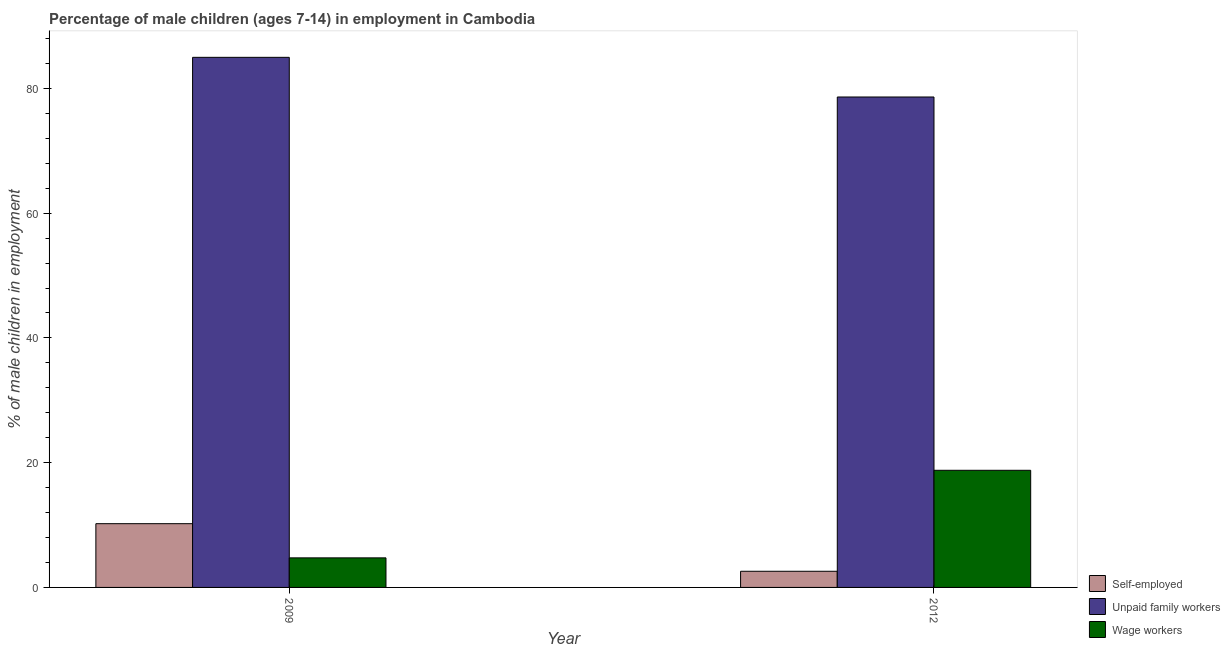Are the number of bars per tick equal to the number of legend labels?
Provide a succinct answer. Yes. How many bars are there on the 1st tick from the left?
Your answer should be compact. 3. What is the percentage of self employed children in 2012?
Your response must be concise. 2.59. Across all years, what is the maximum percentage of self employed children?
Provide a succinct answer. 10.22. Across all years, what is the minimum percentage of self employed children?
Ensure brevity in your answer.  2.59. In which year was the percentage of children employed as wage workers maximum?
Provide a short and direct response. 2012. In which year was the percentage of children employed as unpaid family workers minimum?
Your answer should be very brief. 2012. What is the total percentage of self employed children in the graph?
Your answer should be compact. 12.81. What is the difference between the percentage of self employed children in 2009 and that in 2012?
Provide a succinct answer. 7.63. What is the difference between the percentage of children employed as wage workers in 2012 and the percentage of self employed children in 2009?
Your answer should be compact. 14.04. What is the average percentage of children employed as unpaid family workers per year?
Provide a succinct answer. 81.81. In how many years, is the percentage of children employed as unpaid family workers greater than 28 %?
Your answer should be compact. 2. What is the ratio of the percentage of children employed as unpaid family workers in 2009 to that in 2012?
Provide a short and direct response. 1.08. What does the 2nd bar from the left in 2009 represents?
Ensure brevity in your answer.  Unpaid family workers. What does the 1st bar from the right in 2012 represents?
Offer a very short reply. Wage workers. Is it the case that in every year, the sum of the percentage of self employed children and percentage of children employed as unpaid family workers is greater than the percentage of children employed as wage workers?
Keep it short and to the point. Yes. How many bars are there?
Keep it short and to the point. 6. Are all the bars in the graph horizontal?
Offer a terse response. No. How many years are there in the graph?
Offer a terse response. 2. Are the values on the major ticks of Y-axis written in scientific E-notation?
Provide a succinct answer. No. Does the graph contain any zero values?
Your answer should be very brief. No. Where does the legend appear in the graph?
Give a very brief answer. Bottom right. What is the title of the graph?
Offer a terse response. Percentage of male children (ages 7-14) in employment in Cambodia. What is the label or title of the Y-axis?
Keep it short and to the point. % of male children in employment. What is the % of male children in employment of Self-employed in 2009?
Your response must be concise. 10.22. What is the % of male children in employment of Unpaid family workers in 2009?
Provide a succinct answer. 84.99. What is the % of male children in employment in Wage workers in 2009?
Keep it short and to the point. 4.74. What is the % of male children in employment of Self-employed in 2012?
Your answer should be very brief. 2.59. What is the % of male children in employment of Unpaid family workers in 2012?
Provide a short and direct response. 78.63. What is the % of male children in employment in Wage workers in 2012?
Make the answer very short. 18.78. Across all years, what is the maximum % of male children in employment of Self-employed?
Keep it short and to the point. 10.22. Across all years, what is the maximum % of male children in employment in Unpaid family workers?
Make the answer very short. 84.99. Across all years, what is the maximum % of male children in employment in Wage workers?
Give a very brief answer. 18.78. Across all years, what is the minimum % of male children in employment of Self-employed?
Keep it short and to the point. 2.59. Across all years, what is the minimum % of male children in employment in Unpaid family workers?
Provide a short and direct response. 78.63. Across all years, what is the minimum % of male children in employment of Wage workers?
Your answer should be very brief. 4.74. What is the total % of male children in employment of Self-employed in the graph?
Provide a short and direct response. 12.81. What is the total % of male children in employment in Unpaid family workers in the graph?
Your response must be concise. 163.62. What is the total % of male children in employment of Wage workers in the graph?
Your answer should be very brief. 23.52. What is the difference between the % of male children in employment of Self-employed in 2009 and that in 2012?
Make the answer very short. 7.63. What is the difference between the % of male children in employment of Unpaid family workers in 2009 and that in 2012?
Provide a short and direct response. 6.36. What is the difference between the % of male children in employment in Wage workers in 2009 and that in 2012?
Offer a very short reply. -14.04. What is the difference between the % of male children in employment in Self-employed in 2009 and the % of male children in employment in Unpaid family workers in 2012?
Provide a short and direct response. -68.41. What is the difference between the % of male children in employment in Self-employed in 2009 and the % of male children in employment in Wage workers in 2012?
Give a very brief answer. -8.56. What is the difference between the % of male children in employment of Unpaid family workers in 2009 and the % of male children in employment of Wage workers in 2012?
Ensure brevity in your answer.  66.21. What is the average % of male children in employment in Self-employed per year?
Your response must be concise. 6.41. What is the average % of male children in employment of Unpaid family workers per year?
Offer a terse response. 81.81. What is the average % of male children in employment in Wage workers per year?
Make the answer very short. 11.76. In the year 2009, what is the difference between the % of male children in employment of Self-employed and % of male children in employment of Unpaid family workers?
Your response must be concise. -74.77. In the year 2009, what is the difference between the % of male children in employment of Self-employed and % of male children in employment of Wage workers?
Your answer should be compact. 5.48. In the year 2009, what is the difference between the % of male children in employment in Unpaid family workers and % of male children in employment in Wage workers?
Your answer should be very brief. 80.25. In the year 2012, what is the difference between the % of male children in employment in Self-employed and % of male children in employment in Unpaid family workers?
Provide a succinct answer. -76.04. In the year 2012, what is the difference between the % of male children in employment in Self-employed and % of male children in employment in Wage workers?
Keep it short and to the point. -16.19. In the year 2012, what is the difference between the % of male children in employment in Unpaid family workers and % of male children in employment in Wage workers?
Offer a terse response. 59.85. What is the ratio of the % of male children in employment of Self-employed in 2009 to that in 2012?
Give a very brief answer. 3.95. What is the ratio of the % of male children in employment of Unpaid family workers in 2009 to that in 2012?
Your answer should be very brief. 1.08. What is the ratio of the % of male children in employment of Wage workers in 2009 to that in 2012?
Make the answer very short. 0.25. What is the difference between the highest and the second highest % of male children in employment of Self-employed?
Provide a short and direct response. 7.63. What is the difference between the highest and the second highest % of male children in employment of Unpaid family workers?
Keep it short and to the point. 6.36. What is the difference between the highest and the second highest % of male children in employment in Wage workers?
Keep it short and to the point. 14.04. What is the difference between the highest and the lowest % of male children in employment in Self-employed?
Provide a short and direct response. 7.63. What is the difference between the highest and the lowest % of male children in employment in Unpaid family workers?
Your answer should be compact. 6.36. What is the difference between the highest and the lowest % of male children in employment in Wage workers?
Your answer should be very brief. 14.04. 